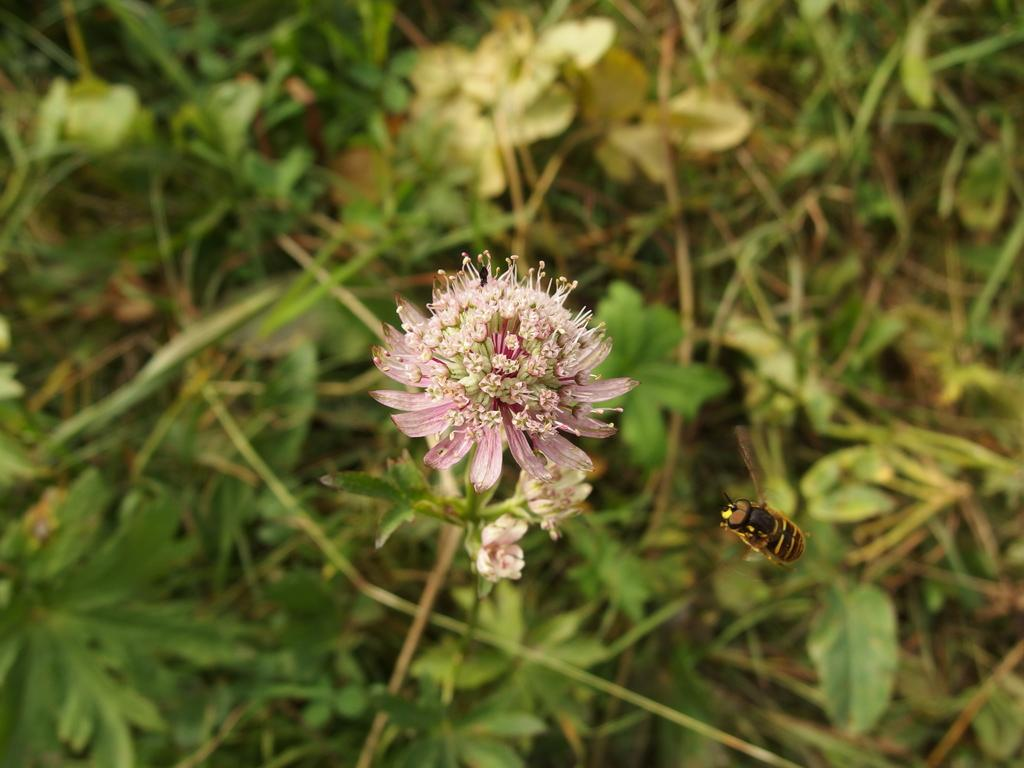What type of living organisms can be seen in the image? Plants and an insect are visible in the image. Can you describe the insect in the image? Unfortunately, the facts provided do not give enough detail to describe the insect. However, we can confirm that there is an insect present. Where is the plastic yak located in the image? There is no plastic yak present in the image. Can you describe the squirrel in the image? There is no squirrel present in the image; only plants and an insect are mentioned in the facts. 